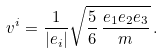Convert formula to latex. <formula><loc_0><loc_0><loc_500><loc_500>v ^ { i } = \frac { 1 } { | e _ { i } | } \sqrt { \frac { 5 } { 6 } \, \frac { e _ { 1 } e _ { 2 } e _ { 3 } } { m } } \, .</formula> 